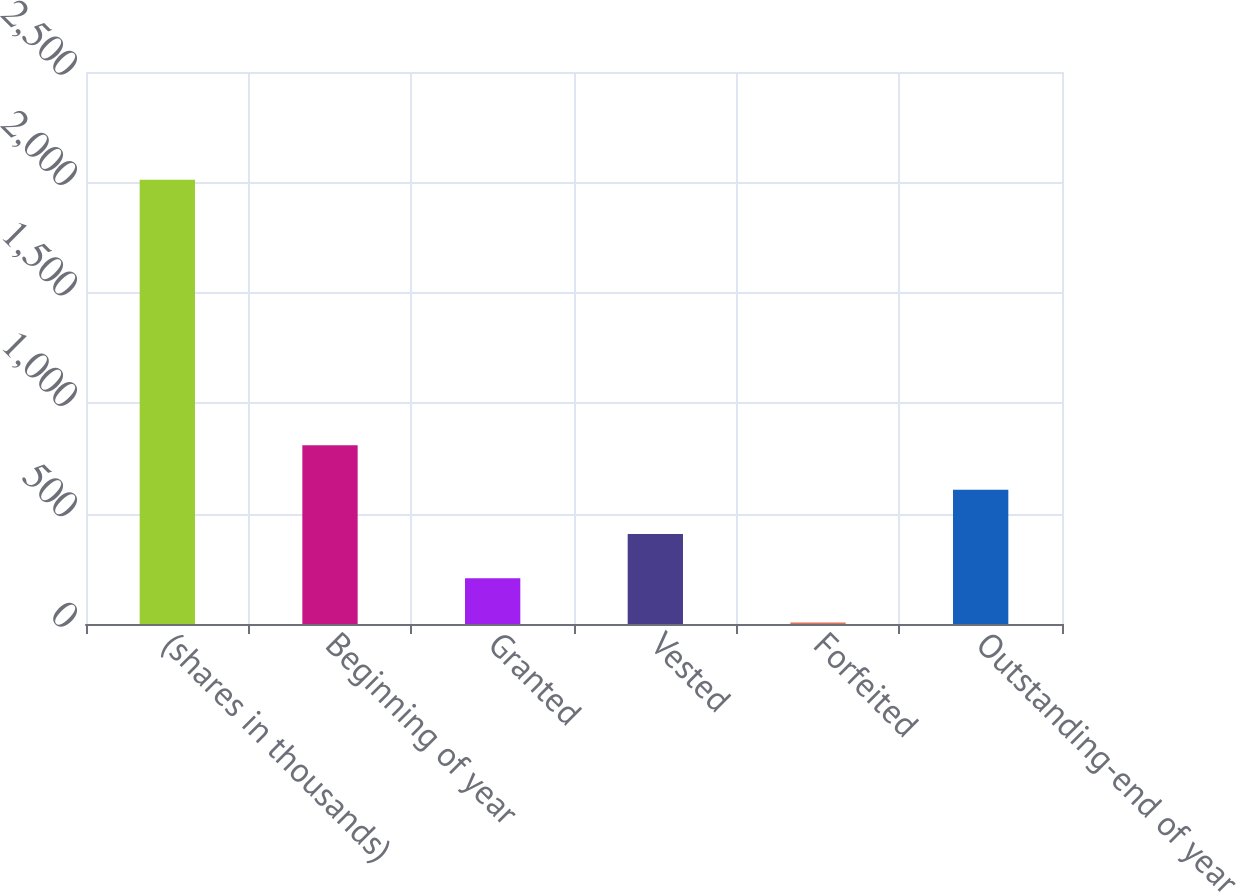Convert chart to OTSL. <chart><loc_0><loc_0><loc_500><loc_500><bar_chart><fcel>(shares in thousands)<fcel>Beginning of year<fcel>Granted<fcel>Vested<fcel>Forfeited<fcel>Outstanding-end of year<nl><fcel>2012<fcel>809<fcel>207.5<fcel>408<fcel>7<fcel>608.5<nl></chart> 